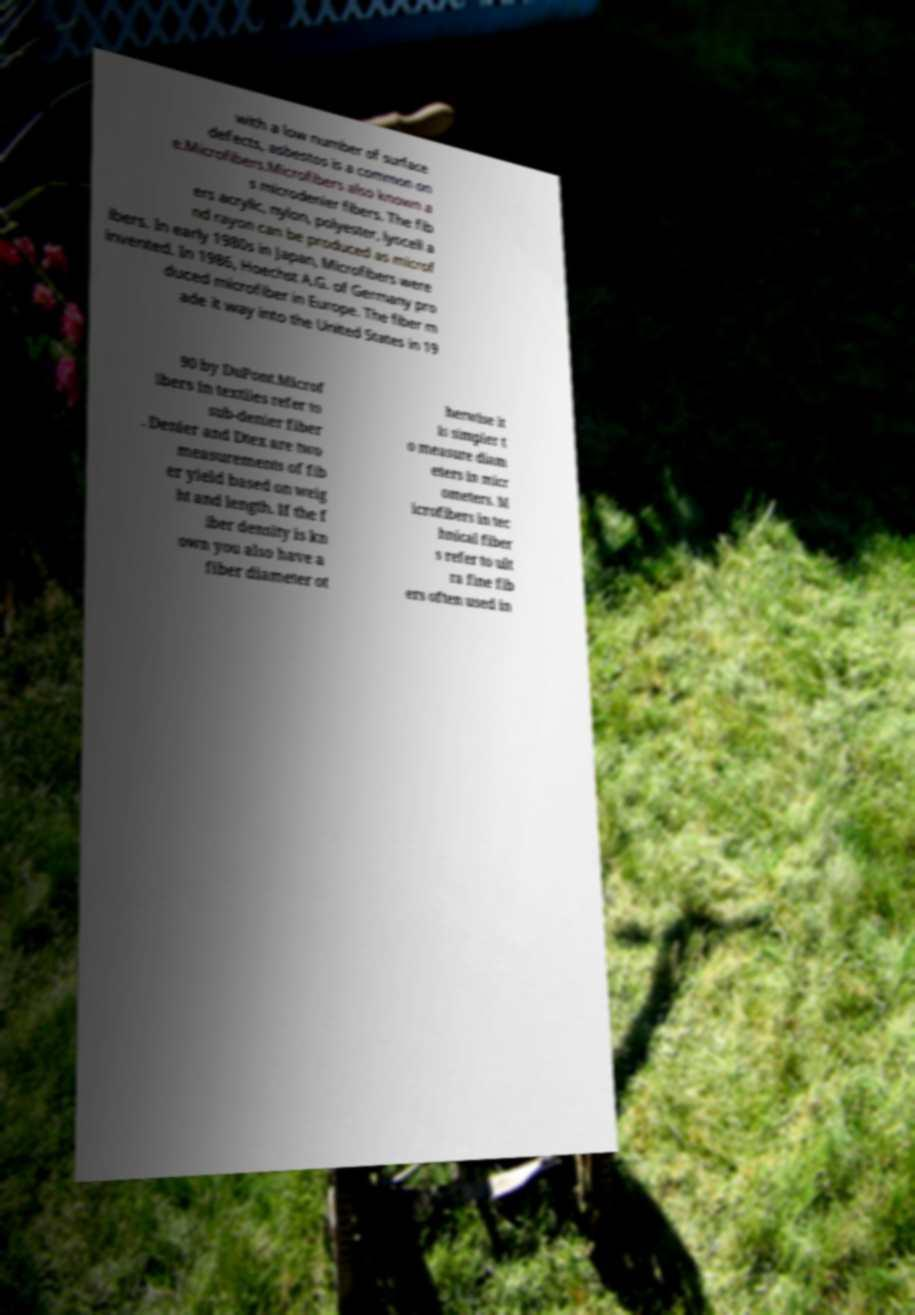Please identify and transcribe the text found in this image. with a low number of surface defects, asbestos is a common on e.Microfibers.Microfibers also known a s microdenier fibers. The fib ers acrylic, nylon, polyester, lyocell a nd rayon can be produced as microf ibers. In early 1980s in Japan, Microfibers were invented. In 1986, Hoechst A.G. of Germany pro duced microfiber in Europe. The fiber m ade it way into the United States in 19 90 by DuPont.Microf ibers in textiles refer to sub-denier fiber . Denier and Dtex are two measurements of fib er yield based on weig ht and length. If the f iber density is kn own you also have a fiber diameter ot herwise it is simpler t o measure diam eters in micr ometers. M icrofibers in tec hnical fiber s refer to ult ra fine fib ers often used in 